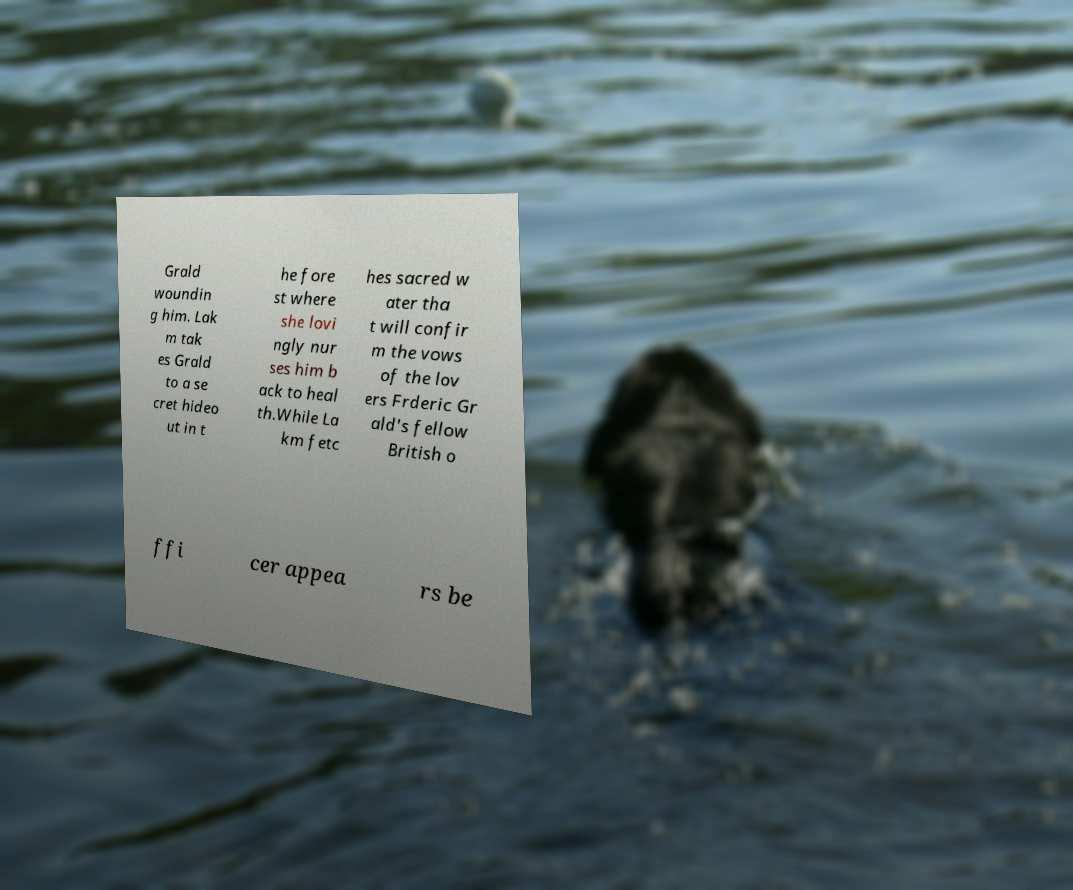Please read and relay the text visible in this image. What does it say? Grald woundin g him. Lak m tak es Grald to a se cret hideo ut in t he fore st where she lovi ngly nur ses him b ack to heal th.While La km fetc hes sacred w ater tha t will confir m the vows of the lov ers Frderic Gr ald's fellow British o ffi cer appea rs be 